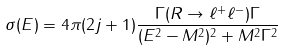Convert formula to latex. <formula><loc_0><loc_0><loc_500><loc_500>\sigma ( E ) = 4 \pi ( 2 j + 1 ) \frac { \Gamma ( R \to \ell ^ { + } \ell ^ { - } ) \Gamma } { ( E ^ { 2 } - M ^ { 2 } ) ^ { 2 } + M ^ { 2 } \Gamma ^ { 2 } }</formula> 